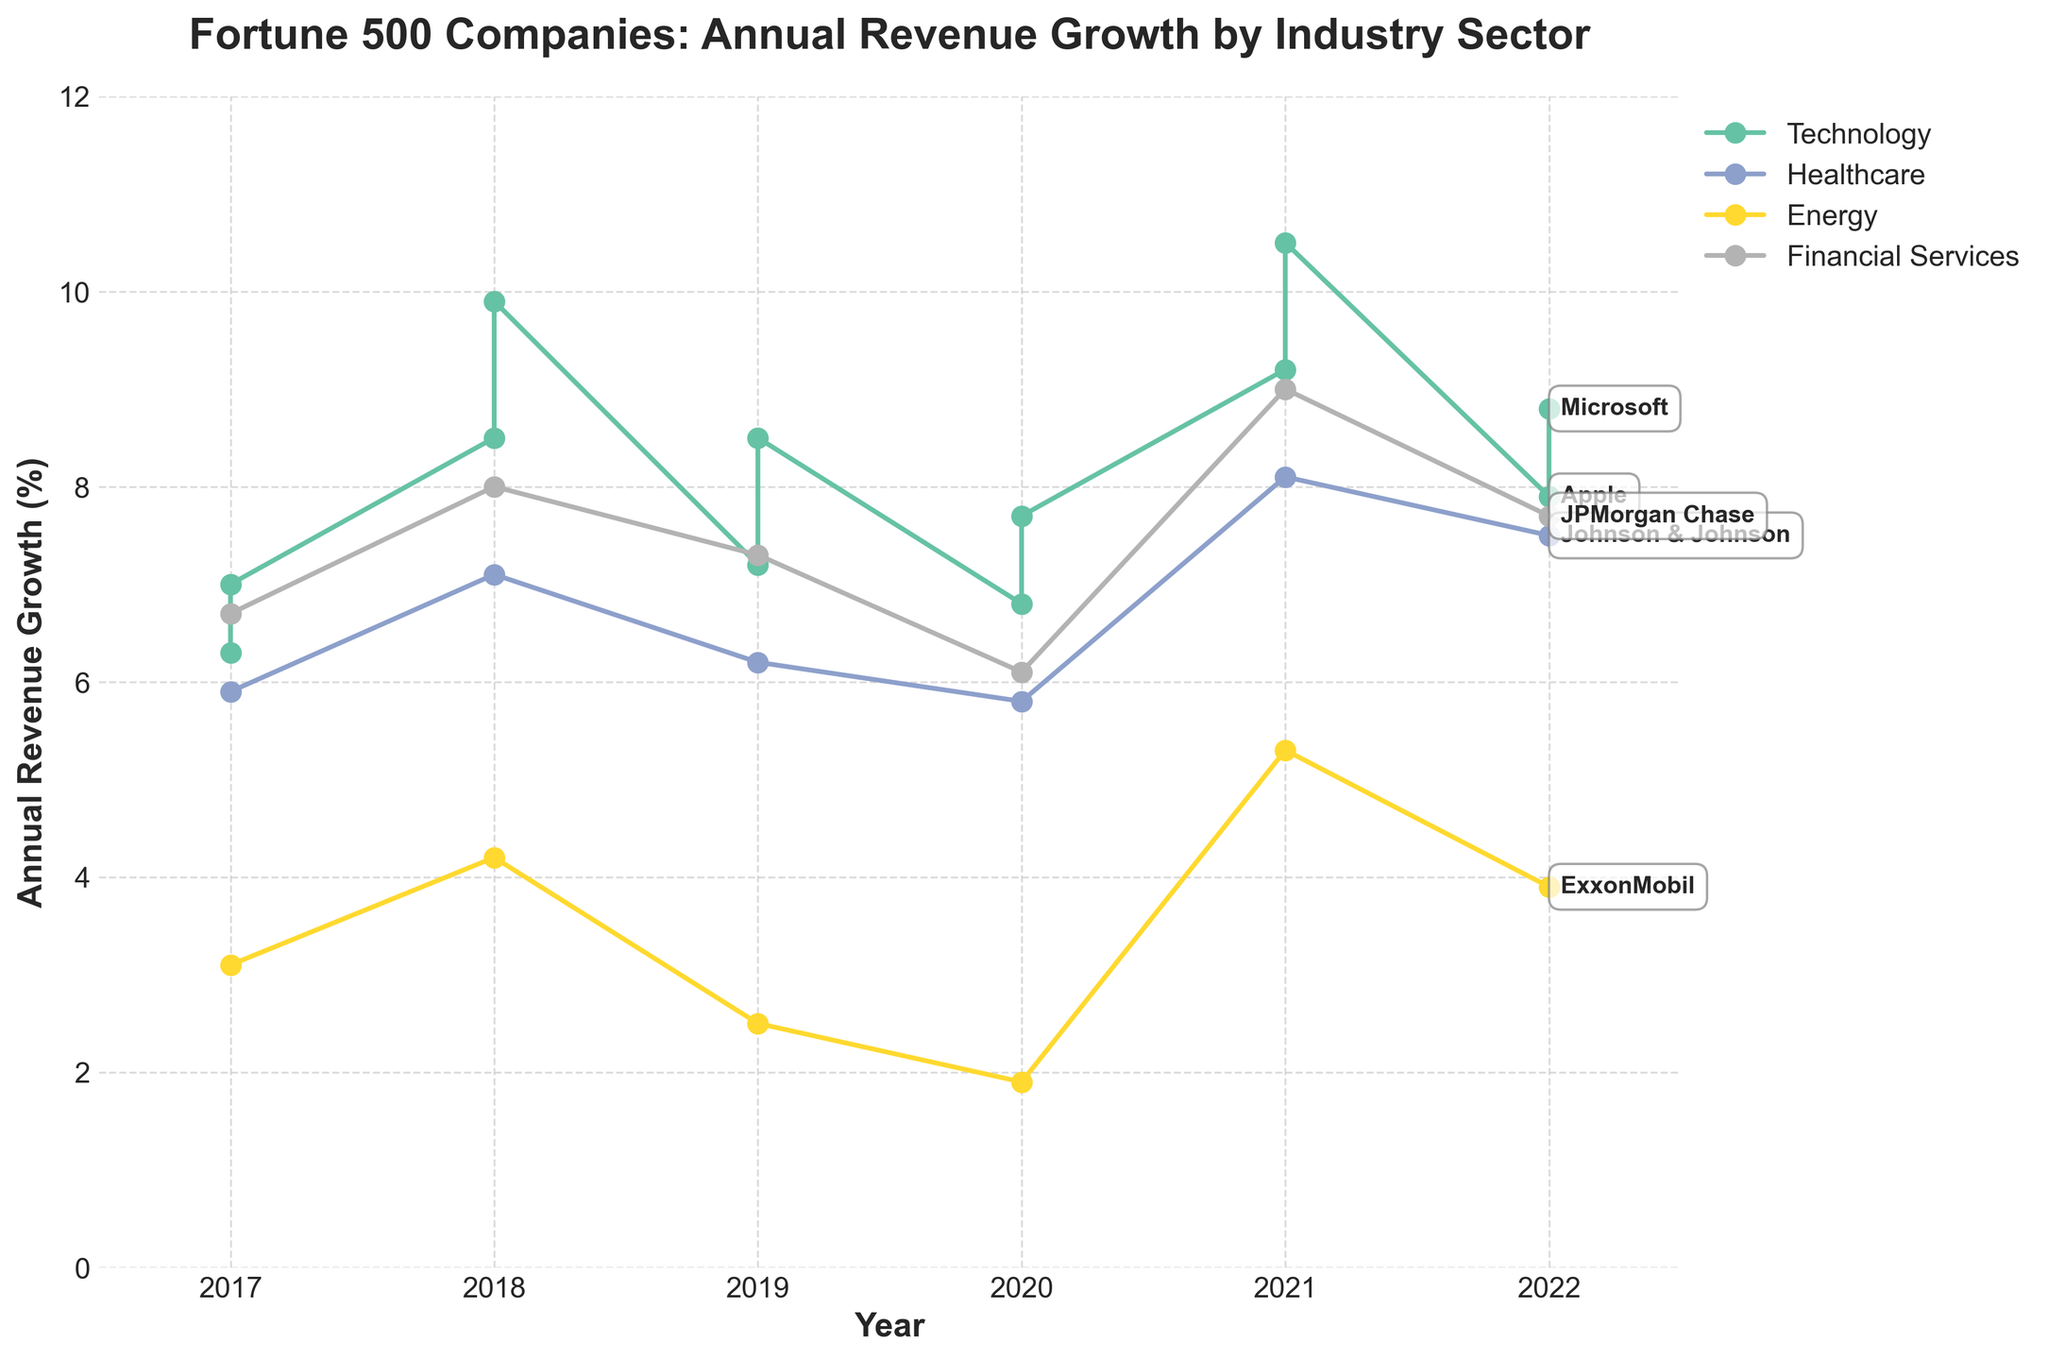What is the title of the figure? The title is usually located at the top of the figure and provides a summary of what the chart represents. In this case, it reads "Fortune 500 Companies: Annual Revenue Growth by Industry Sector".
Answer: Fortune 500 Companies: Annual Revenue Growth by Industry Sector What is the average annual revenue growth for Johnson & Johnson in the years 2019 and 2020? To find the average, add the annual revenue growth percentages for 2019 and 2020 and divide by 2: (6.20 + 5.80)/2 = 6.00.
Answer: 6.00 Which industry sector had the highest revenue growth in 2021? In 2021, the revenue growth values are compared across all industry sectors. The highest value is observed in Technology (Apple at 9.20 and Microsoft at 10.50).
Answer: Technology What is the trend in the annual revenue growth for ExxonMobil from 2017 to 2021? Observing the data points for ExxonMobil in the Energy sector from 2017 (3.10), 2018 (4.20), 2019 (2.50), 2020 (1.90), to 2021 (5.30), one can see a general decline from 2017 to 2020 followed by a significant increase in 2021.
Answer: Generally declined from 2017 to 2020, then increased in 2021 Does the Financial Services sector have a steady annual revenue growth over the years? By examining the data points for JPMorgan Chase in the Financial Services sector from 2017 to 2022 (6.70, 8.00, 7.30, 6.10, 9.00, 7.70), one can see fluctuations rather than a steady trend.
Answer: No, it fluctuates Which company showed the most consistent revenue growth in the Technology sector between 2017 and 2022? By comparing the growth figures for Apple and Microsoft in the Technology sector from 2017 to 2022, one can see that Microsoft consistently shows higher growth each year compared to Apple.
Answer: Microsoft By how much did Apple's annual revenue growth increase from 2020 to 2021? Subtract the 2020 value (6.80) from the 2021 value (9.20) to find the difference: 9.20 - 6.80 = 2.40.
Answer: 2.40 What was the revenue growth percentage for the Healthcare sector in 2022? The annual revenue growth percentage for Johnson & Johnson in 2022 is given in the dataset: 7.50.
Answer: 7.50 